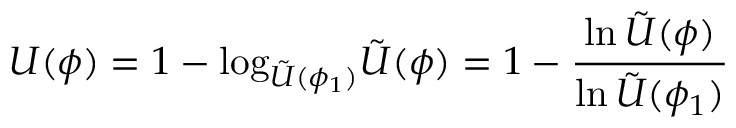<formula> <loc_0><loc_0><loc_500><loc_500>U ( \phi ) = 1 - \log _ { \tilde { U } ( \phi _ { 1 } ) } \tilde { U } ( \phi ) = 1 - \frac { \ln \, \tilde { U } ( \phi ) } { \ln \, \tilde { U } ( \phi _ { 1 } ) }</formula> 